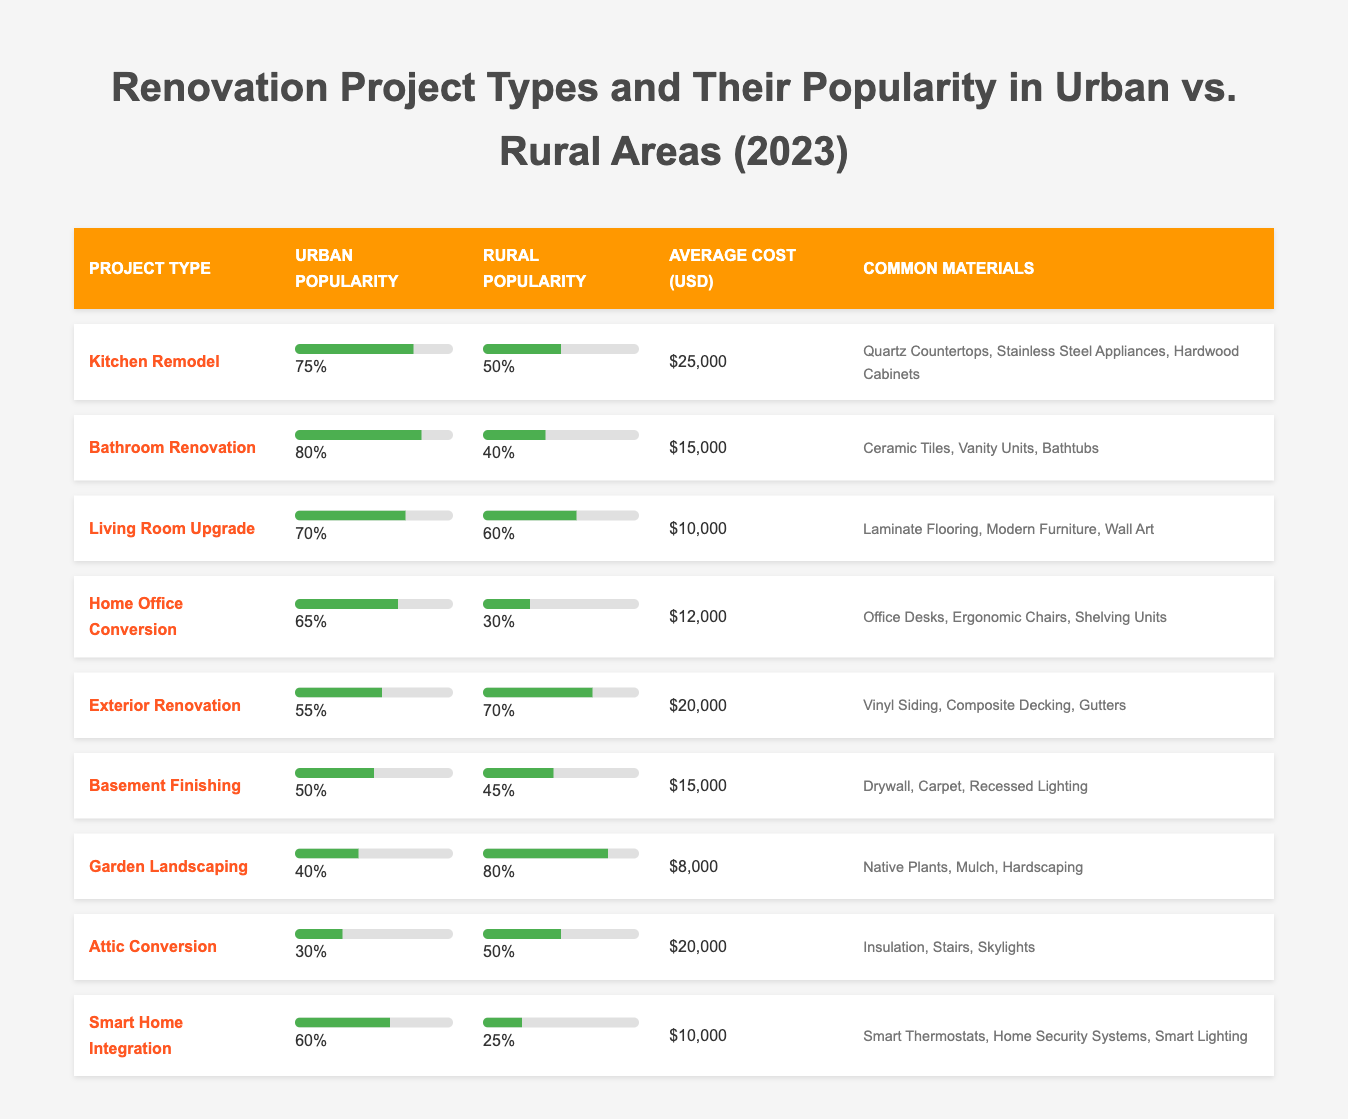What renovation project has the highest urban popularity? Looking at the "Urban Popularity" column, the project with the highest value is "Bathroom Renovation" at 80%.
Answer: Bathroom Renovation Which renovation project has the lowest average cost? By scanning the "Average Cost (USD)" column, "Garden Landscaping" has the lowest value at $8,000.
Answer: $8,000 Is the popularity of Kitchen Remodel higher in urban or rural areas? Comparing the urban popularity (75%) and rural popularity (50%), Kitchen Remodel is higher in urban areas.
Answer: Yes What is the difference in urban popularity between Exterior Renovation and Garden Landscaping? The urban popularity of Exterior Renovation is 55% and Garden Landscaping is 40%, so the difference is 55% - 40% = 15%.
Answer: 15% Which renovation project has a higher rural popularity, Attic Conversion or Home Office Conversion? Attic Conversion has a rural popularity of 50% while Home Office Conversion has 30%. Therefore, Attic Conversion is more popular in rural areas.
Answer: Attic Conversion Calculate the average rural popularity of all renovation projects. The rural popularity values are 50, 40, 60, 30, 70, 45, 80, 50, and 25. Adding these values gives 75 + 40 + 60 + 30 + 70 + 45 + 80 + 50 + 25 = 525. Dividing by the number of projects (9) results in an average of 525 / 9 = 58.33%.
Answer: 58.33% What is the most expensive renovation project, and what is its cost? Scanning through the "Average Cost (USD)" column, "Kitchen Remodel" is the most expensive at $25,000.
Answer: Kitchen Remodel, $25,000 Is it true that Garden Landscaping is more popular in rural areas than in urban areas? The urban popularity of Garden Landscaping is 40%, while its rural popularity is 80%. Therefore, it is indeed more popular in rural areas.
Answer: Yes Which project has both urban and rural popularity under 50%? The projects "Basement Finishing" and "Garden Landscaping" have urban popularity of 50% or lower. However, only "Garden Landscaping" has a rural popularity above 50% while "Home Office Conversion" has 30%. Therefore, both are under 50% in urban popularity.
Answer: Home Office Conversion Calculate the total average cost of all renovation projects. Adding the costs: 25000 + 15000 + 10000 + 12000 + 20000 + 15000 + 8000 + 20000 + 10000 = 103000. Dividing by 9 gives an average of 11444.44.
Answer: 11444.44 